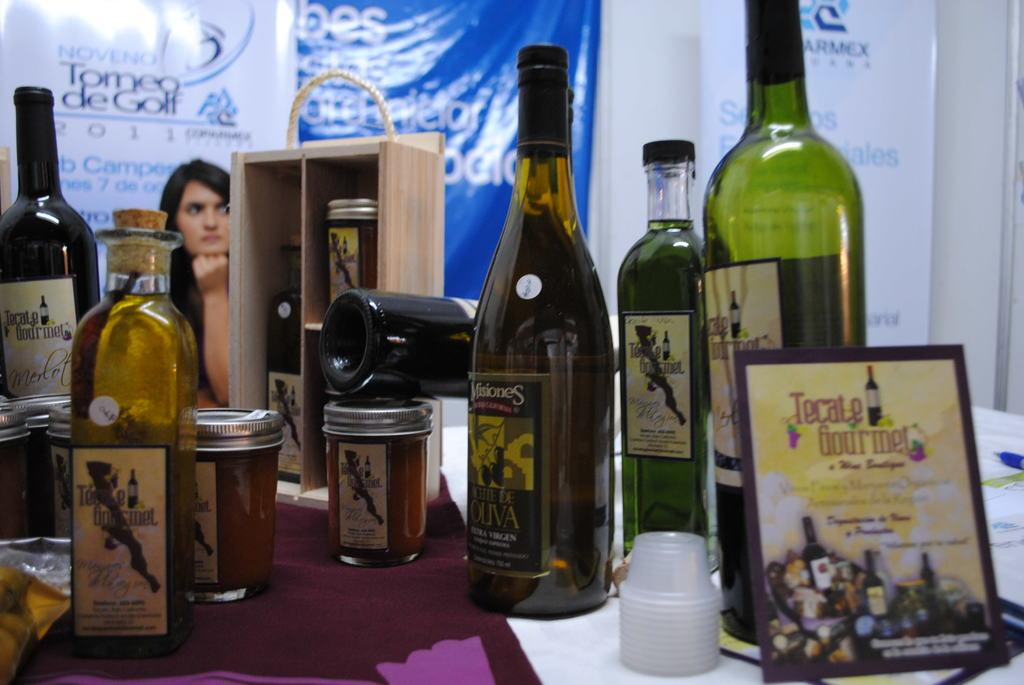Provide a one-sentence caption for the provided image. A sign for Tecate Gourmet leans against a bottle. 